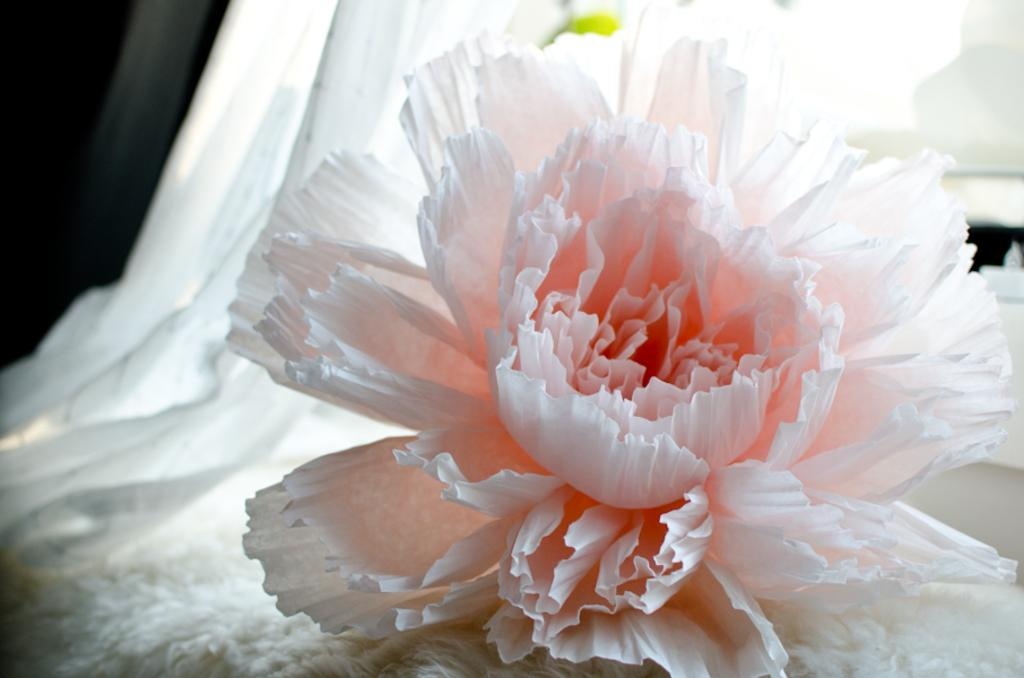What is the main subject of the image? There is a flower in the center of the image. Can you describe the flower in more detail? Unfortunately, the facts provided do not give any additional details about the flower. Is there anything else in the image besides the flower? The facts provided do not mention any other objects or subjects in the image. What type of underwear is the flower wearing in the image? There is no underwear present in the image, as it features a flower and flowers do not wear underwear. 